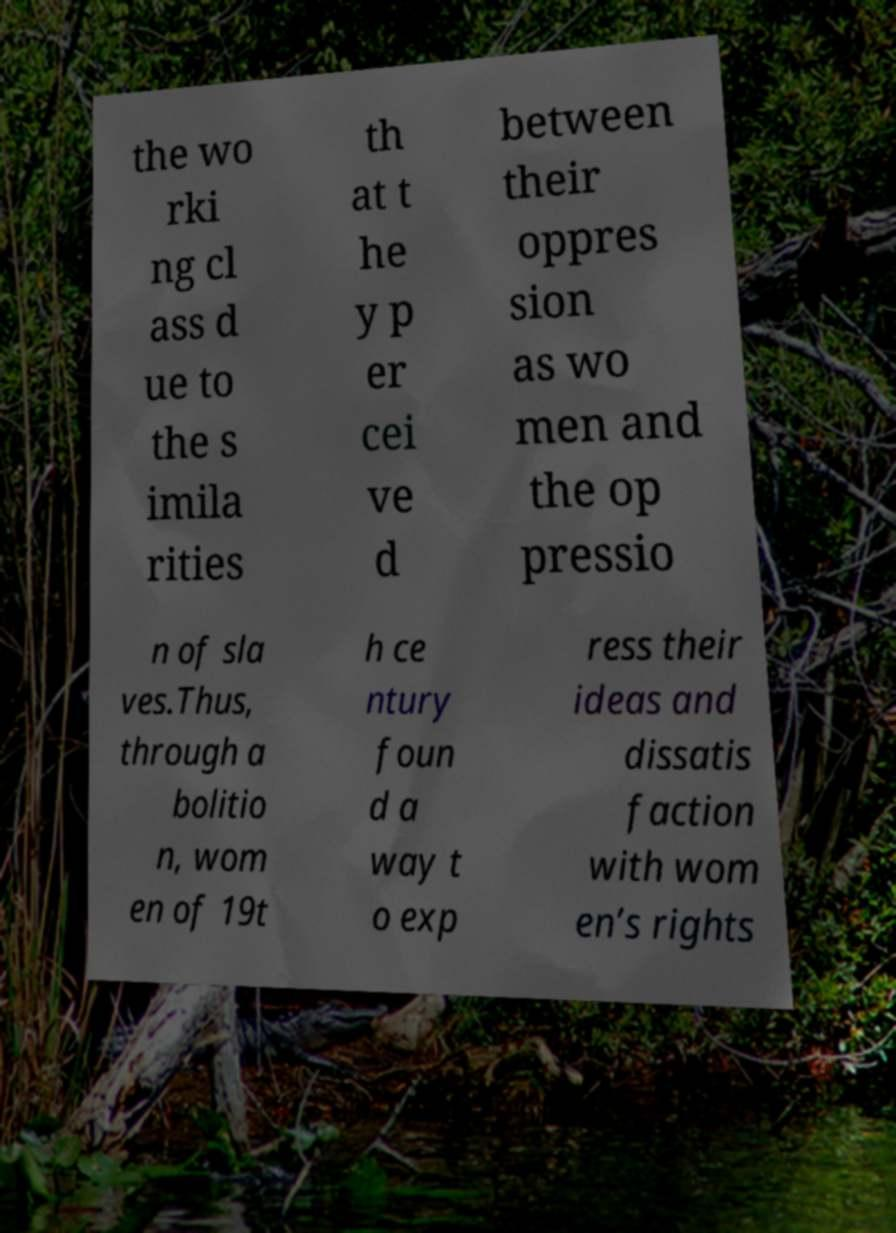I need the written content from this picture converted into text. Can you do that? the wo rki ng cl ass d ue to the s imila rities th at t he y p er cei ve d between their oppres sion as wo men and the op pressio n of sla ves.Thus, through a bolitio n, wom en of 19t h ce ntury foun d a way t o exp ress their ideas and dissatis faction with wom en’s rights 